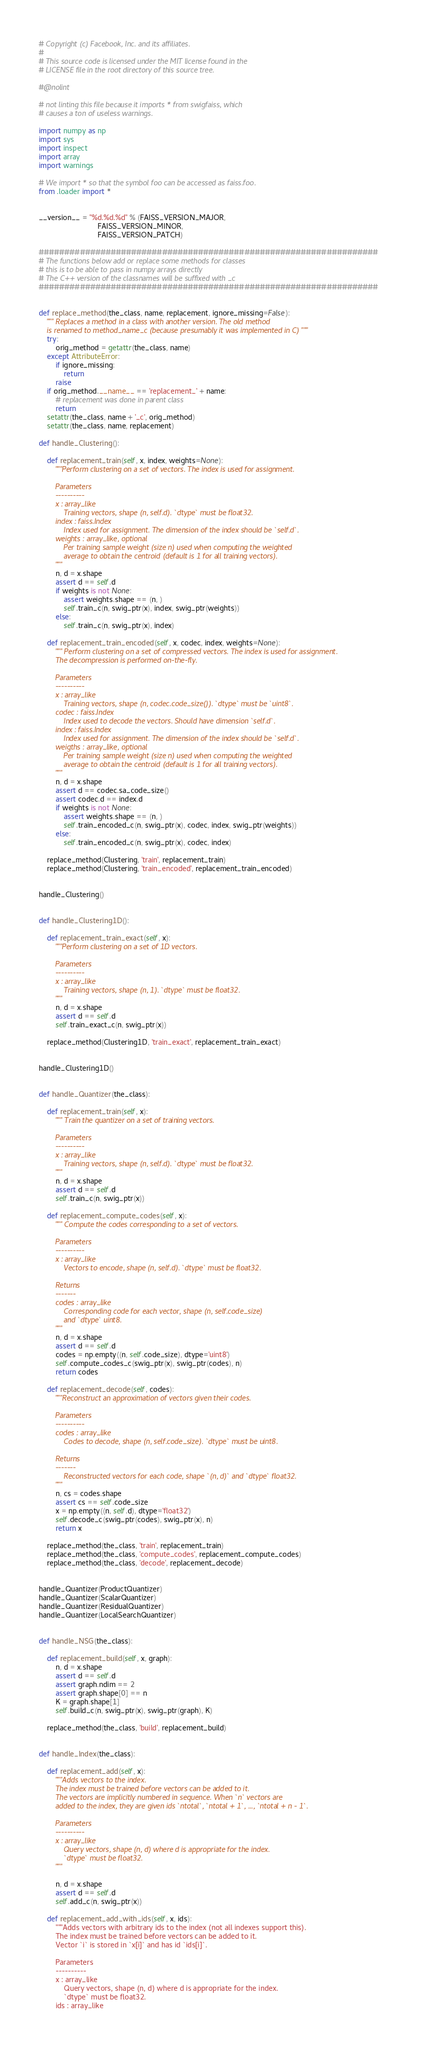<code> <loc_0><loc_0><loc_500><loc_500><_Python_># Copyright (c) Facebook, Inc. and its affiliates.
#
# This source code is licensed under the MIT license found in the
# LICENSE file in the root directory of this source tree.

#@nolint

# not linting this file because it imports * from swigfaiss, which
# causes a ton of useless warnings.

import numpy as np
import sys
import inspect
import array
import warnings

# We import * so that the symbol foo can be accessed as faiss.foo.
from .loader import *


__version__ = "%d.%d.%d" % (FAISS_VERSION_MAJOR,
                            FAISS_VERSION_MINOR,
                            FAISS_VERSION_PATCH)

##################################################################
# The functions below add or replace some methods for classes
# this is to be able to pass in numpy arrays directly
# The C++ version of the classnames will be suffixed with _c
##################################################################


def replace_method(the_class, name, replacement, ignore_missing=False):
    """ Replaces a method in a class with another version. The old method
    is renamed to method_name_c (because presumably it was implemented in C) """
    try:
        orig_method = getattr(the_class, name)
    except AttributeError:
        if ignore_missing:
            return
        raise
    if orig_method.__name__ == 'replacement_' + name:
        # replacement was done in parent class
        return
    setattr(the_class, name + '_c', orig_method)
    setattr(the_class, name, replacement)

def handle_Clustering():

    def replacement_train(self, x, index, weights=None):
        """Perform clustering on a set of vectors. The index is used for assignment.

        Parameters
        ----------
        x : array_like
            Training vectors, shape (n, self.d). `dtype` must be float32.
        index : faiss.Index
            Index used for assignment. The dimension of the index should be `self.d`.
        weights : array_like, optional
            Per training sample weight (size n) used when computing the weighted
            average to obtain the centroid (default is 1 for all training vectors).
        """
        n, d = x.shape
        assert d == self.d
        if weights is not None:
            assert weights.shape == (n, )
            self.train_c(n, swig_ptr(x), index, swig_ptr(weights))
        else:
            self.train_c(n, swig_ptr(x), index)

    def replacement_train_encoded(self, x, codec, index, weights=None):
        """ Perform clustering on a set of compressed vectors. The index is used for assignment.
        The decompression is performed on-the-fly.

        Parameters
        ----------
        x : array_like
            Training vectors, shape (n, codec.code_size()). `dtype` must be `uint8`.
        codec : faiss.Index
            Index used to decode the vectors. Should have dimension `self.d`.
        index : faiss.Index
            Index used for assignment. The dimension of the index should be `self.d`.
        weigths : array_like, optional
            Per training sample weight (size n) used when computing the weighted
            average to obtain the centroid (default is 1 for all training vectors).
        """
        n, d = x.shape
        assert d == codec.sa_code_size()
        assert codec.d == index.d
        if weights is not None:
            assert weights.shape == (n, )
            self.train_encoded_c(n, swig_ptr(x), codec, index, swig_ptr(weights))
        else:
            self.train_encoded_c(n, swig_ptr(x), codec, index)

    replace_method(Clustering, 'train', replacement_train)
    replace_method(Clustering, 'train_encoded', replacement_train_encoded)


handle_Clustering()


def handle_Clustering1D():

    def replacement_train_exact(self, x):
        """Perform clustering on a set of 1D vectors.

        Parameters
        ----------
        x : array_like
            Training vectors, shape (n, 1). `dtype` must be float32.
        """
        n, d = x.shape
        assert d == self.d
        self.train_exact_c(n, swig_ptr(x))

    replace_method(Clustering1D, 'train_exact', replacement_train_exact)


handle_Clustering1D()


def handle_Quantizer(the_class):

    def replacement_train(self, x):
        """ Train the quantizer on a set of training vectors.

        Parameters
        ----------
        x : array_like
            Training vectors, shape (n, self.d). `dtype` must be float32.
        """
        n, d = x.shape
        assert d == self.d
        self.train_c(n, swig_ptr(x))

    def replacement_compute_codes(self, x):
        """ Compute the codes corresponding to a set of vectors.

        Parameters
        ----------
        x : array_like
            Vectors to encode, shape (n, self.d). `dtype` must be float32.

        Returns
        -------
        codes : array_like
            Corresponding code for each vector, shape (n, self.code_size)
            and `dtype` uint8.
        """
        n, d = x.shape
        assert d == self.d
        codes = np.empty((n, self.code_size), dtype='uint8')
        self.compute_codes_c(swig_ptr(x), swig_ptr(codes), n)
        return codes

    def replacement_decode(self, codes):
        """Reconstruct an approximation of vectors given their codes.

        Parameters
        ----------
        codes : array_like
            Codes to decode, shape (n, self.code_size). `dtype` must be uint8.

        Returns
        -------
            Reconstructed vectors for each code, shape `(n, d)` and `dtype` float32.
        """
        n, cs = codes.shape
        assert cs == self.code_size
        x = np.empty((n, self.d), dtype='float32')
        self.decode_c(swig_ptr(codes), swig_ptr(x), n)
        return x

    replace_method(the_class, 'train', replacement_train)
    replace_method(the_class, 'compute_codes', replacement_compute_codes)
    replace_method(the_class, 'decode', replacement_decode)


handle_Quantizer(ProductQuantizer)
handle_Quantizer(ScalarQuantizer)
handle_Quantizer(ResidualQuantizer)
handle_Quantizer(LocalSearchQuantizer)


def handle_NSG(the_class):

    def replacement_build(self, x, graph):
        n, d = x.shape
        assert d == self.d
        assert graph.ndim == 2
        assert graph.shape[0] == n
        K = graph.shape[1]
        self.build_c(n, swig_ptr(x), swig_ptr(graph), K)

    replace_method(the_class, 'build', replacement_build)


def handle_Index(the_class):

    def replacement_add(self, x):
        """Adds vectors to the index.
        The index must be trained before vectors can be added to it.
        The vectors are implicitly numbered in sequence. When `n` vectors are
        added to the index, they are given ids `ntotal`, `ntotal + 1`, ..., `ntotal + n - 1`.

        Parameters
        ----------
        x : array_like
            Query vectors, shape (n, d) where d is appropriate for the index.
            `dtype` must be float32.
        """

        n, d = x.shape
        assert d == self.d
        self.add_c(n, swig_ptr(x))

    def replacement_add_with_ids(self, x, ids):
        """Adds vectors with arbitrary ids to the index (not all indexes support this).
        The index must be trained before vectors can be added to it.
        Vector `i` is stored in `x[i]` and has id `ids[i]`.

        Parameters
        ----------
        x : array_like
            Query vectors, shape (n, d) where d is appropriate for the index.
            `dtype` must be float32.
        ids : array_like</code> 